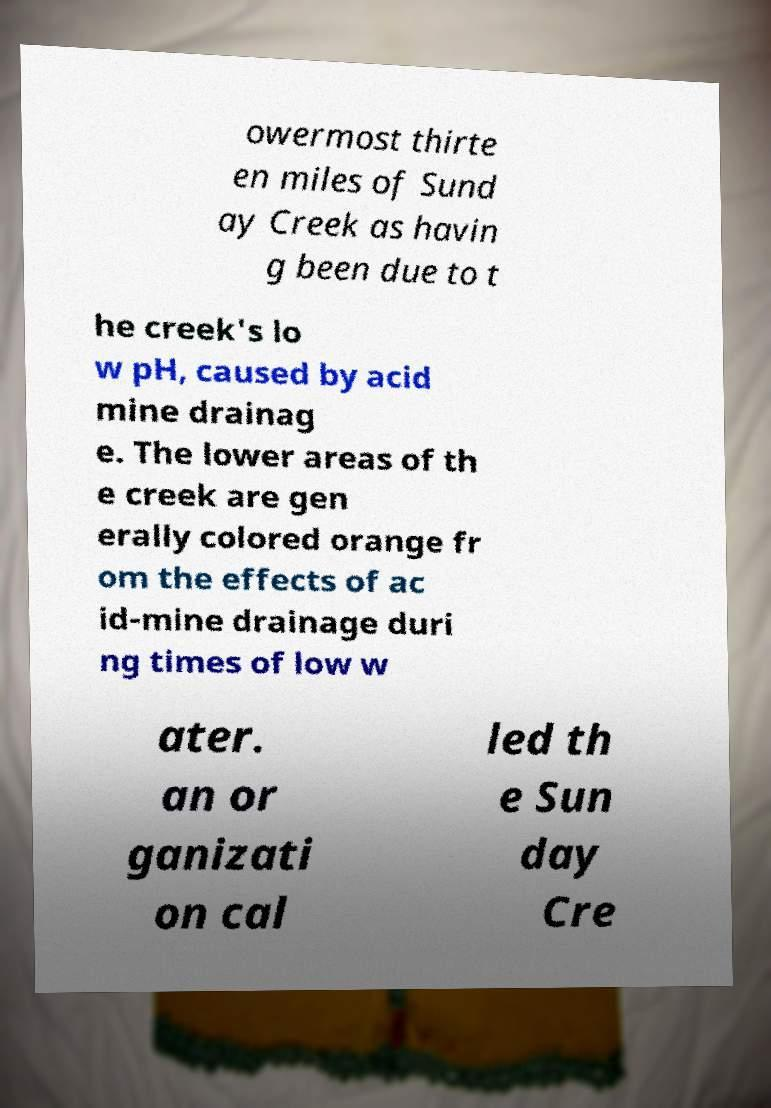Could you assist in decoding the text presented in this image and type it out clearly? owermost thirte en miles of Sund ay Creek as havin g been due to t he creek's lo w pH, caused by acid mine drainag e. The lower areas of th e creek are gen erally colored orange fr om the effects of ac id-mine drainage duri ng times of low w ater. an or ganizati on cal led th e Sun day Cre 